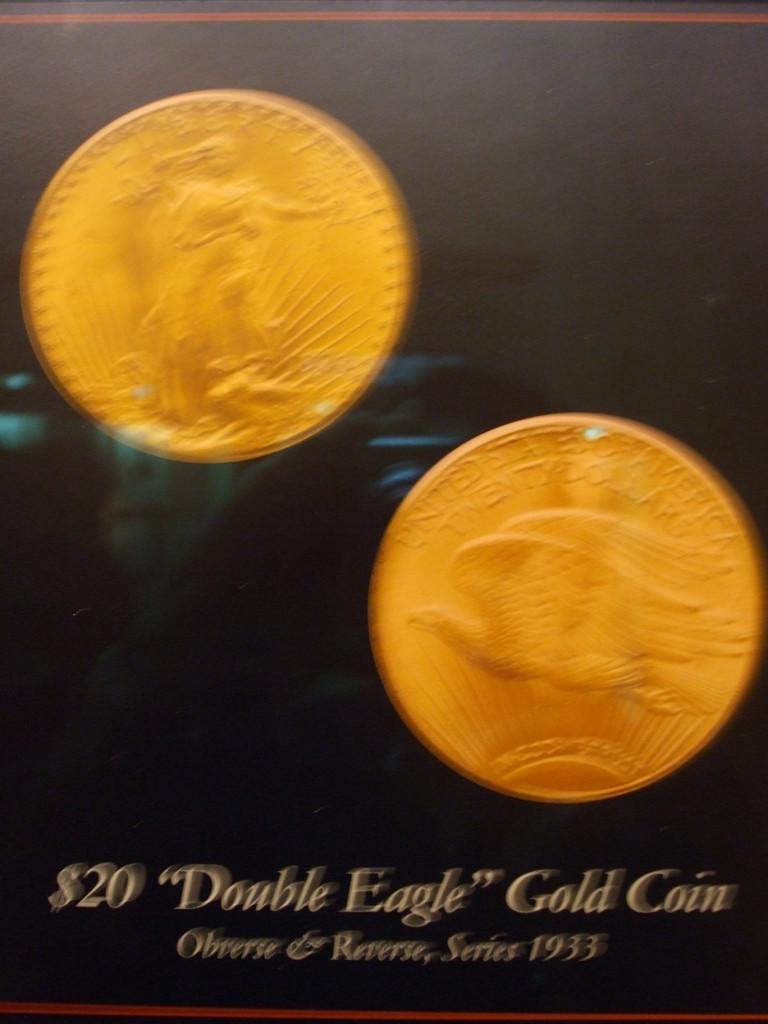Is this an investment company?
Give a very brief answer. Unanswerable. How much is the gold coin?
Provide a succinct answer. $20. 